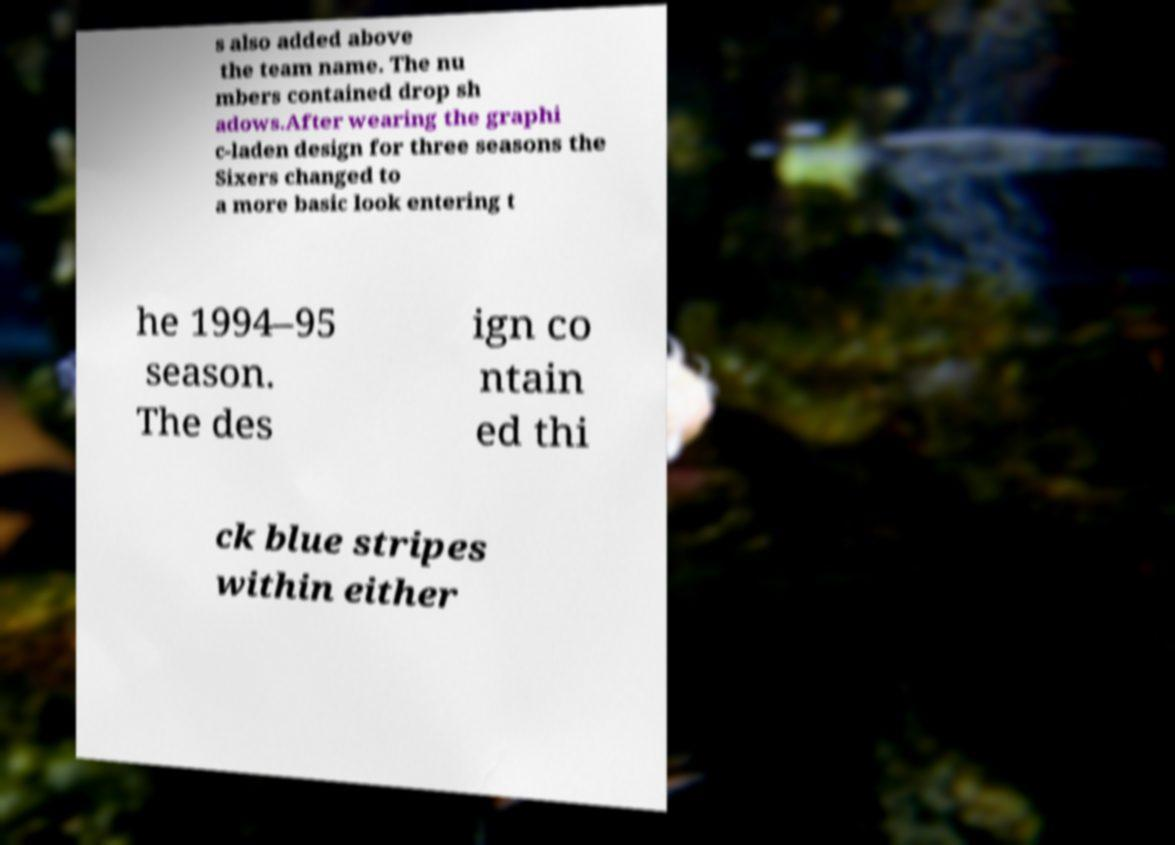I need the written content from this picture converted into text. Can you do that? s also added above the team name. The nu mbers contained drop sh adows.After wearing the graphi c-laden design for three seasons the Sixers changed to a more basic look entering t he 1994–95 season. The des ign co ntain ed thi ck blue stripes within either 